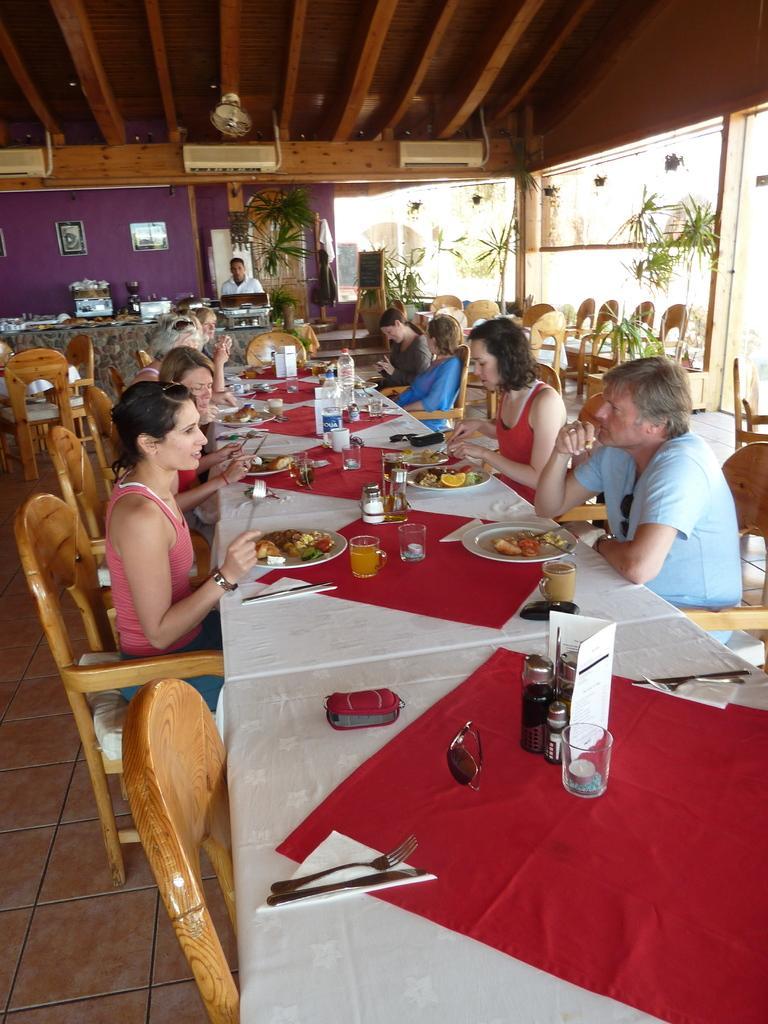Can you describe this image briefly? In this image i can see a number of persons sitting around the table ,on the table there is plates and foodstuffs and glasses kept on the table and right side i can see a flower pots and there are some chairs kept on the floor and there is a man stand on the middle in front of the table. 